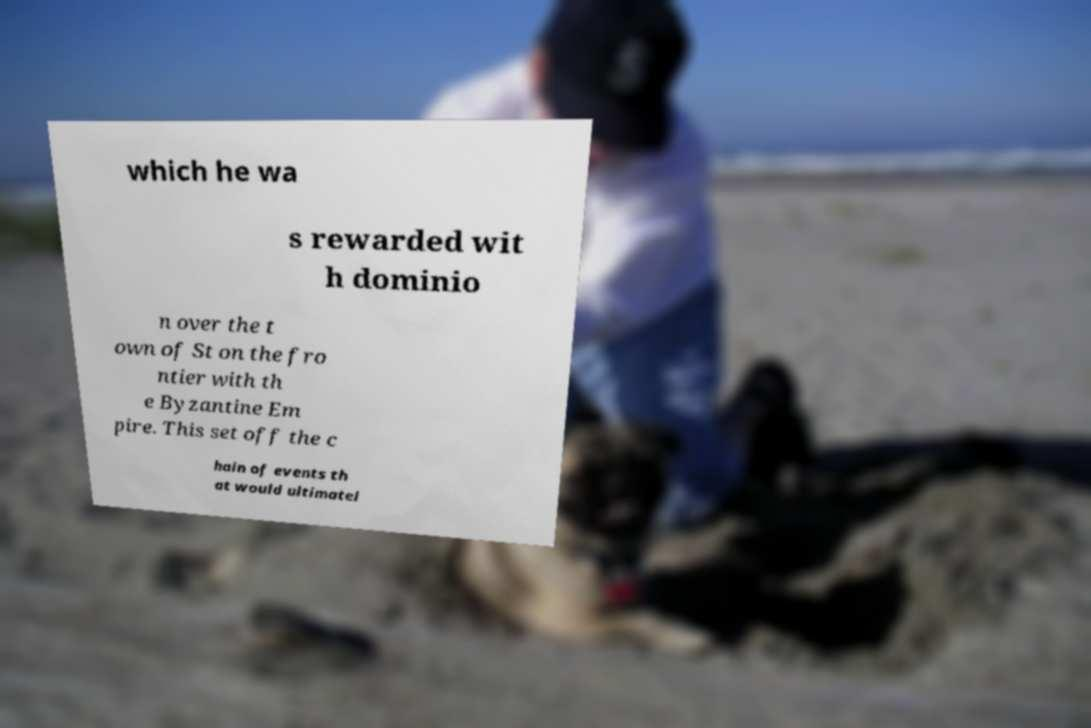What messages or text are displayed in this image? I need them in a readable, typed format. which he wa s rewarded wit h dominio n over the t own of St on the fro ntier with th e Byzantine Em pire. This set off the c hain of events th at would ultimatel 